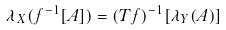Convert formula to latex. <formula><loc_0><loc_0><loc_500><loc_500>\lambda _ { X } ( f ^ { - 1 } [ A ] ) = ( T f ) ^ { - 1 } [ \lambda _ { Y } ( A ) ]</formula> 